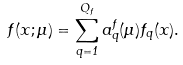<formula> <loc_0><loc_0><loc_500><loc_500>f ( x ; \mu ) = \sum _ { q = 1 } ^ { Q _ { f } } a ^ { f } _ { q } ( \mu ) f _ { q } ( x ) .</formula> 